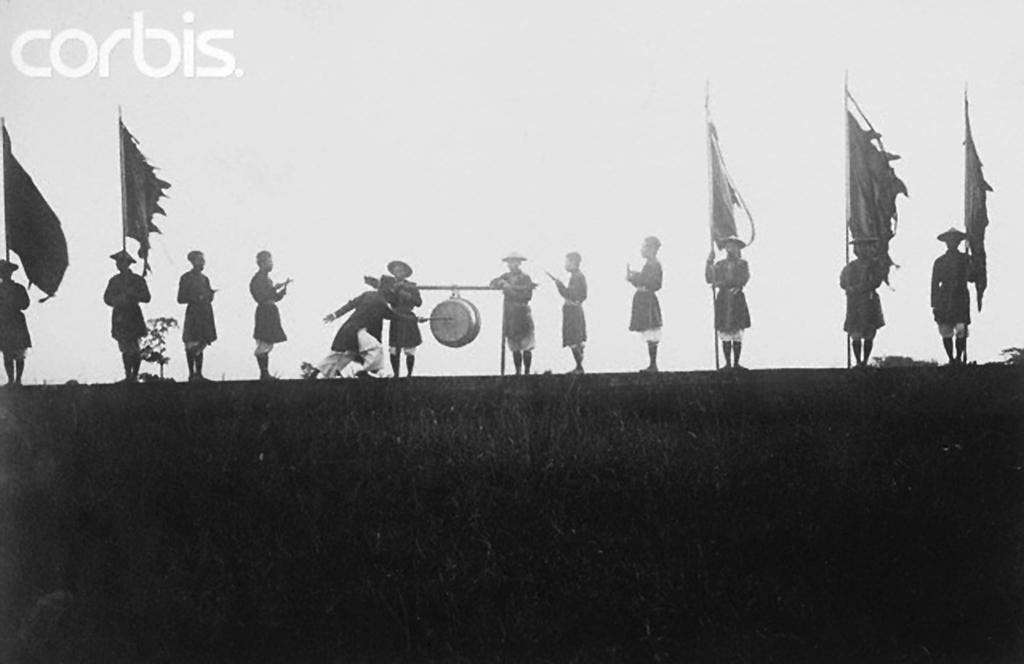What is the overall lighting condition in the image? The image is dark. What type of living organisms can be seen in the image? Plants are visible in the image. Can you describe the people in the image? There are people standing in the image. What additional objects can be seen in the image? There are flags and an object hanging from a rod in the image. What can be seen in the background of the image? The sky is visible in the background of the image. What type of motion can be seen in the image? There is no motion visible in the image; it is a still photograph. Can you tell me the relationship between the people in the image? The provided facts do not give any information about the relationships between the people in the image. How does the earthquake affect the objects in the image? There is no earthquake present in the image; it is a still photograph. 